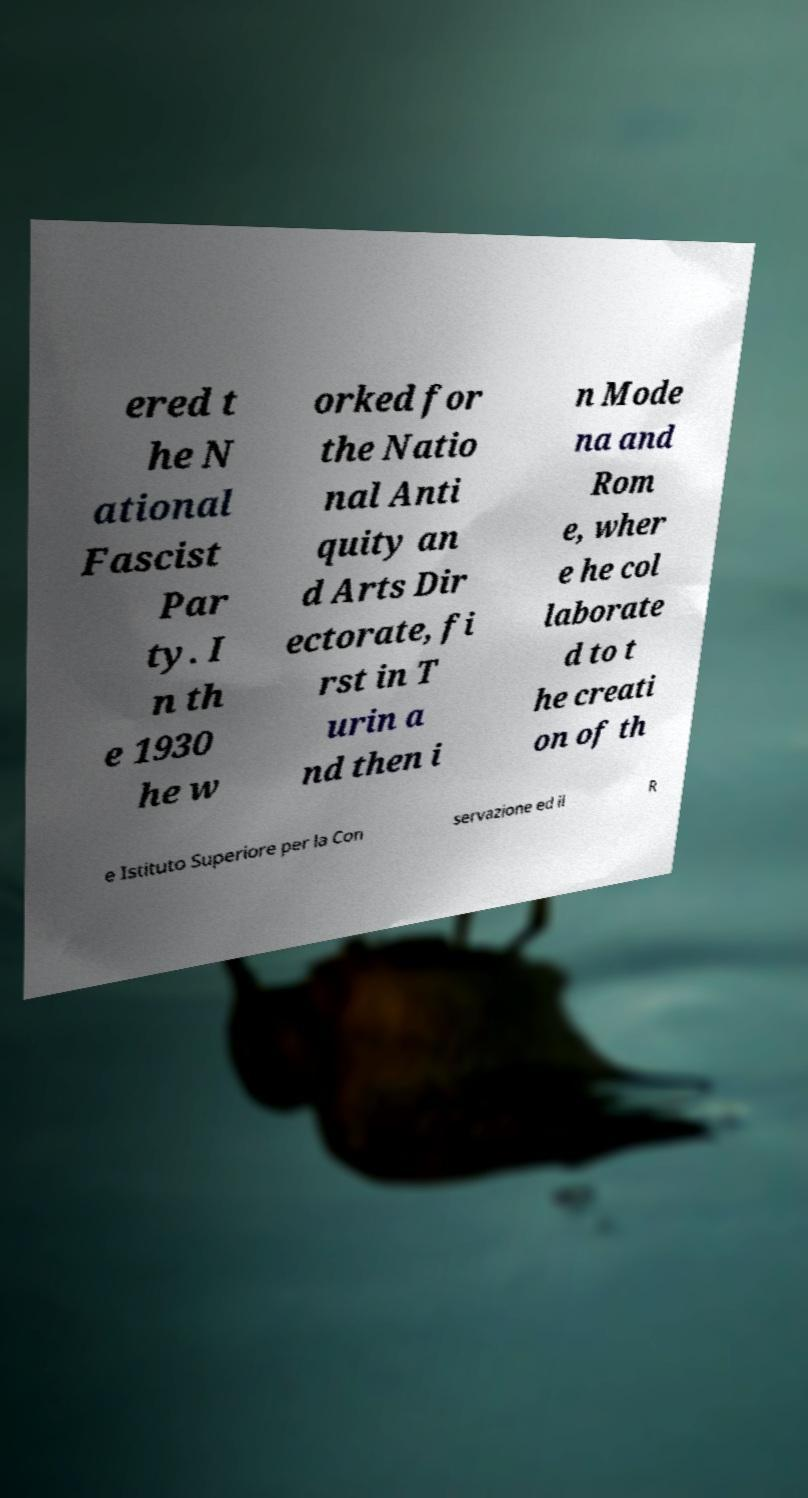Could you assist in decoding the text presented in this image and type it out clearly? ered t he N ational Fascist Par ty. I n th e 1930 he w orked for the Natio nal Anti quity an d Arts Dir ectorate, fi rst in T urin a nd then i n Mode na and Rom e, wher e he col laborate d to t he creati on of th e Istituto Superiore per la Con servazione ed il R 